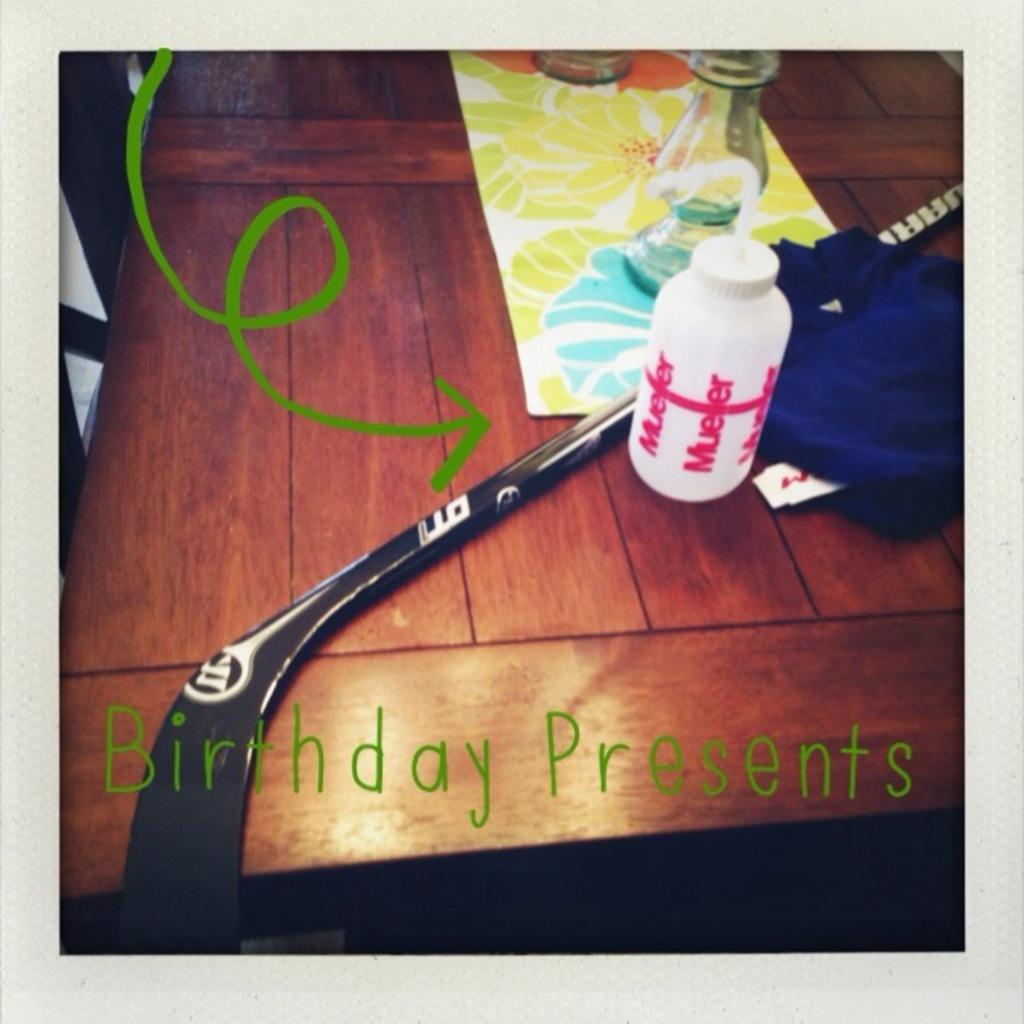What is the main piece of furniture in the image? There is a table in the image. What items can be seen on the table? There are bottled and a stick on the table. Are there any accessories on the table? Yes, there is a table mat and a cloth on the table. What is the context of the image, based on the phrase at the bottom? The phrase "birthday presents" suggests that the items on the table are presents for a birthday. What type of curtain can be seen hanging from the stick in the image? There is no curtain present in the image; the stick is not used for hanging curtains. 